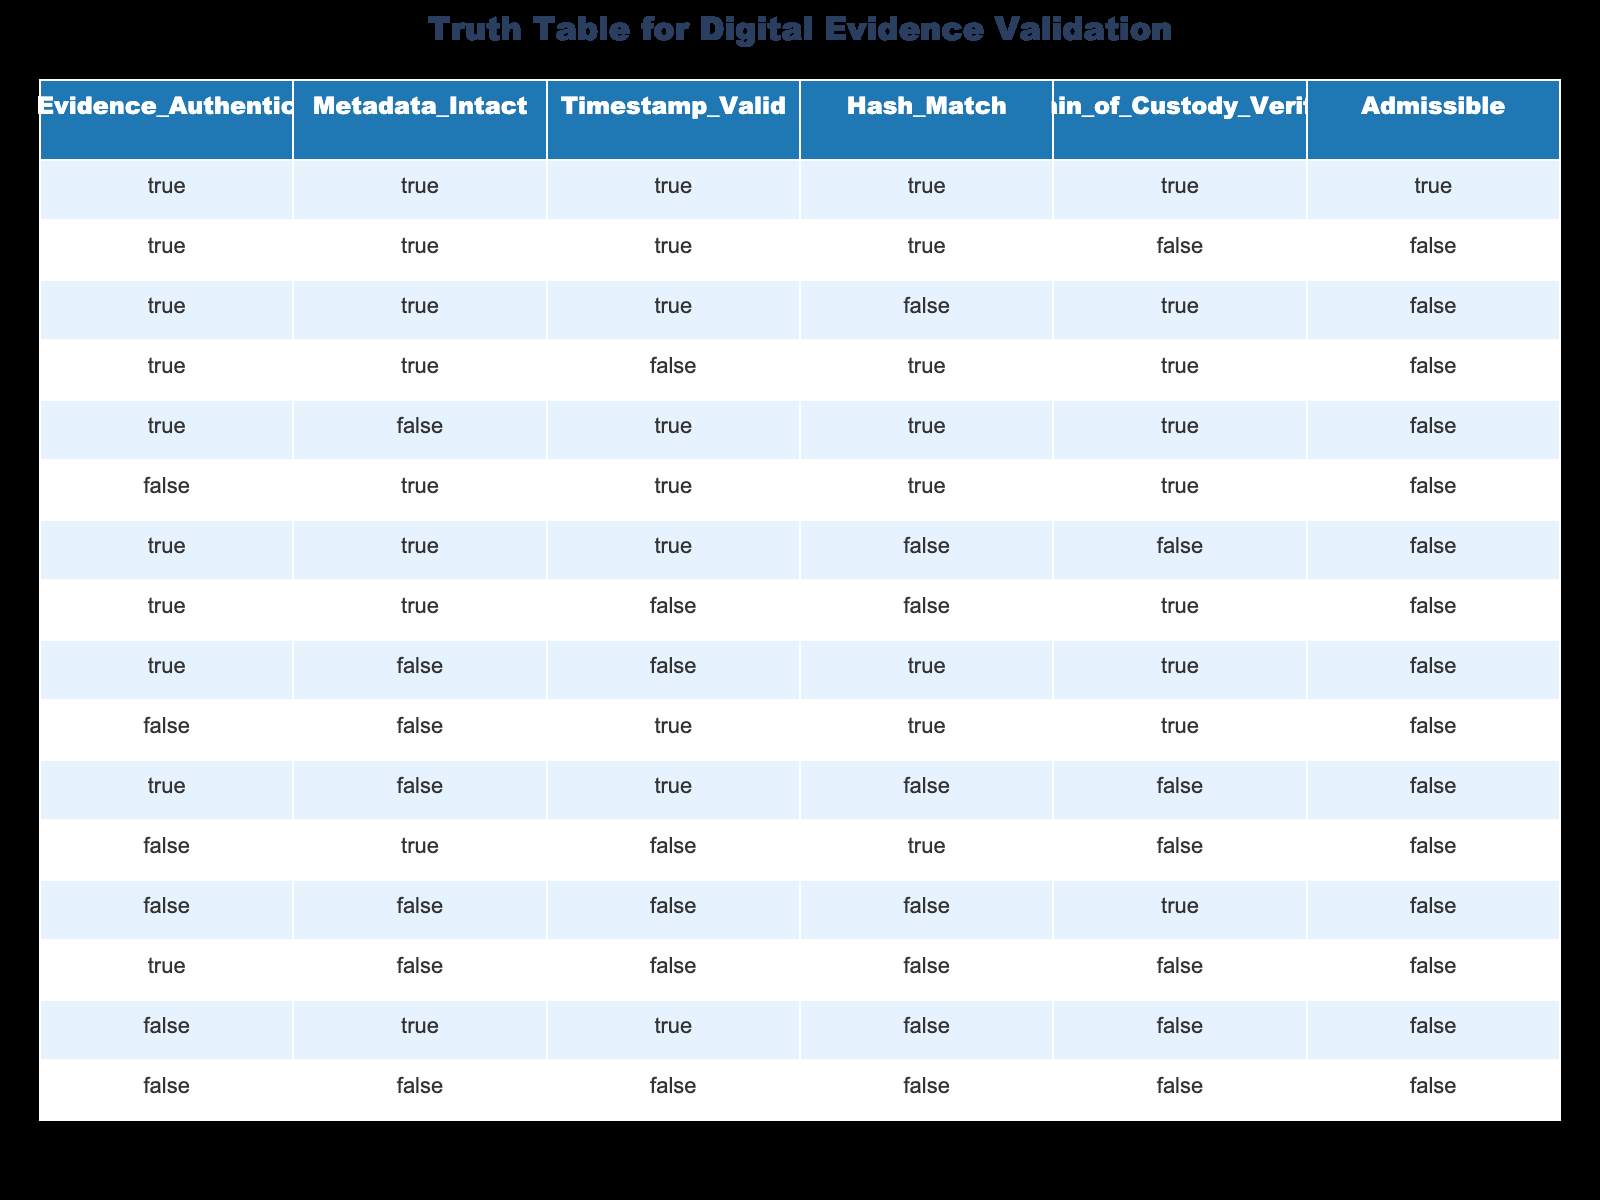What is the total number of instances where the evidence was found to be authentic? In the table, there are 8 instances where the "Evidence_Authentic" column is TRUE. These rows are 1, 2, 3, 4, 5, 7, 11, and 13.
Answer: 8 How many instances show that all conditions for evidence validation are met? Only the first row meets all conditions, where all columns—'Evidence_Authentic', 'Metadata_Intact', 'Timestamp_Valid', 'Hash_Match', 'Chain_of_Custody_Verified'—are TRUE.
Answer: 1 Is it true that when 'Chain_of_Custody_Verified' is FALSE, the 'Admissible' status is also FALSE? Looking at rows 2, 6, 7, 10, 12, and 14, whenever 'Chain_of_Custody_Verified' is FALSE, 'Admissible' is indeed FALSE. Thus, the statement holds true for all instances.
Answer: Yes What percentage of instances where 'Hash_Match' is FALSE also have 'Admissible' status as FALSE? There are 6 instances with 'Hash_Match' FALSE (rows 3, 7, 8, 9, 11, and 13). In 5 of these cases, 'Admissible' is also FALSE, giving a percentage of (5/6)*100 = 83.33%.
Answer: 83.33% How many rows contain instances where 'Evidence_Authentic' is TRUE and 'Admissible' is TRUE? To find this, we check the rows for both conditions: the only row that satisfies both 'Evidence_Authentic' being TRUE and 'Admissible' being TRUE is row 1.
Answer: 1 If 'Metadata_Intact' is TRUE, what is the least number of FALSE conditions that can be present? Looking at cases where 'Metadata_Intact' is TRUE (rows 1, 2, 3, 4, 5, 7, 11, and 13), the minimum number of FALSE conditions is zero when 'Admissible' is TRUE, so the least is '0'.
Answer: 0 Is it possible for 'Timestamp_Valid' to be TRUE while 'Admissible' is FALSE? Yes, in row 11, 'Timestamp_Valid' is TRUE but 'Admissible' is FALSE, validating that possibility.
Answer: Yes Find the average number of TRUE values across the columns for the instances marked as FALSE for 'Evidence_Authentic'. There are 8 rows with 'Evidence_Authentic' FALSE: rows 6, 9, 10, 12, 13, 14, 15, and 16. Summing the TRUE values gives us a total of 11 TRUE values among those instances. There are 8 rows, so the average is 11/8 = 1.375, resulting in 1.375 TRUE values on average.
Answer: 1.375 